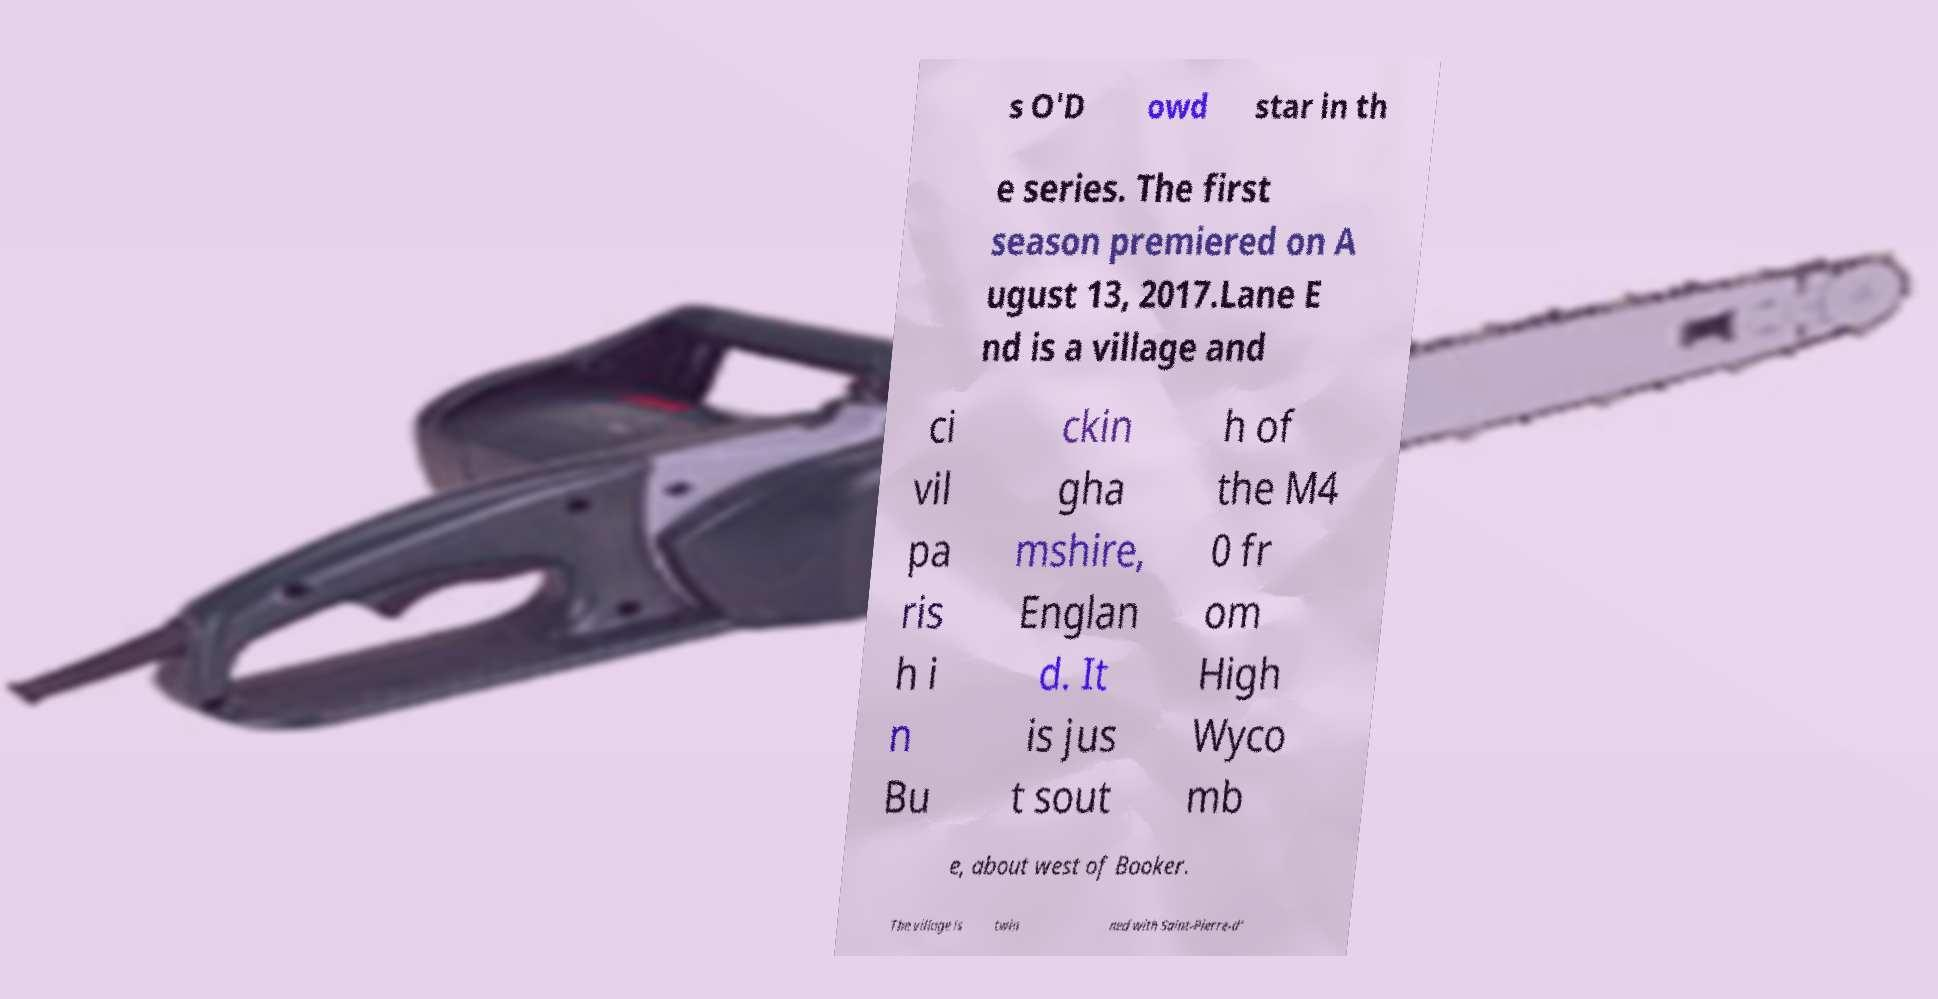What messages or text are displayed in this image? I need them in a readable, typed format. s O'D owd star in th e series. The first season premiered on A ugust 13, 2017.Lane E nd is a village and ci vil pa ris h i n Bu ckin gha mshire, Englan d. It is jus t sout h of the M4 0 fr om High Wyco mb e, about west of Booker. The village is twin ned with Saint-Pierre-d' 